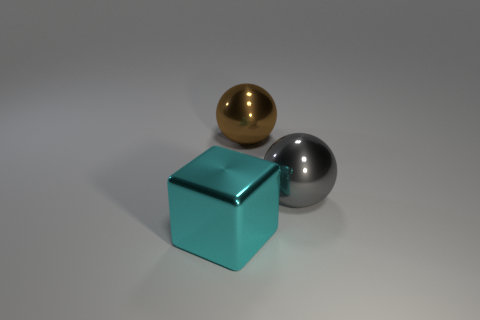Subtract 1 spheres. How many spheres are left? 1 Add 1 brown spheres. How many objects exist? 4 Subtract all blocks. How many objects are left? 2 Add 3 large brown shiny spheres. How many large brown shiny spheres exist? 4 Subtract 1 cyan cubes. How many objects are left? 2 Subtract all yellow spheres. Subtract all brown cylinders. How many spheres are left? 2 Subtract all blue cylinders. How many gray spheres are left? 1 Subtract all large blue shiny balls. Subtract all brown objects. How many objects are left? 2 Add 1 large cubes. How many large cubes are left? 2 